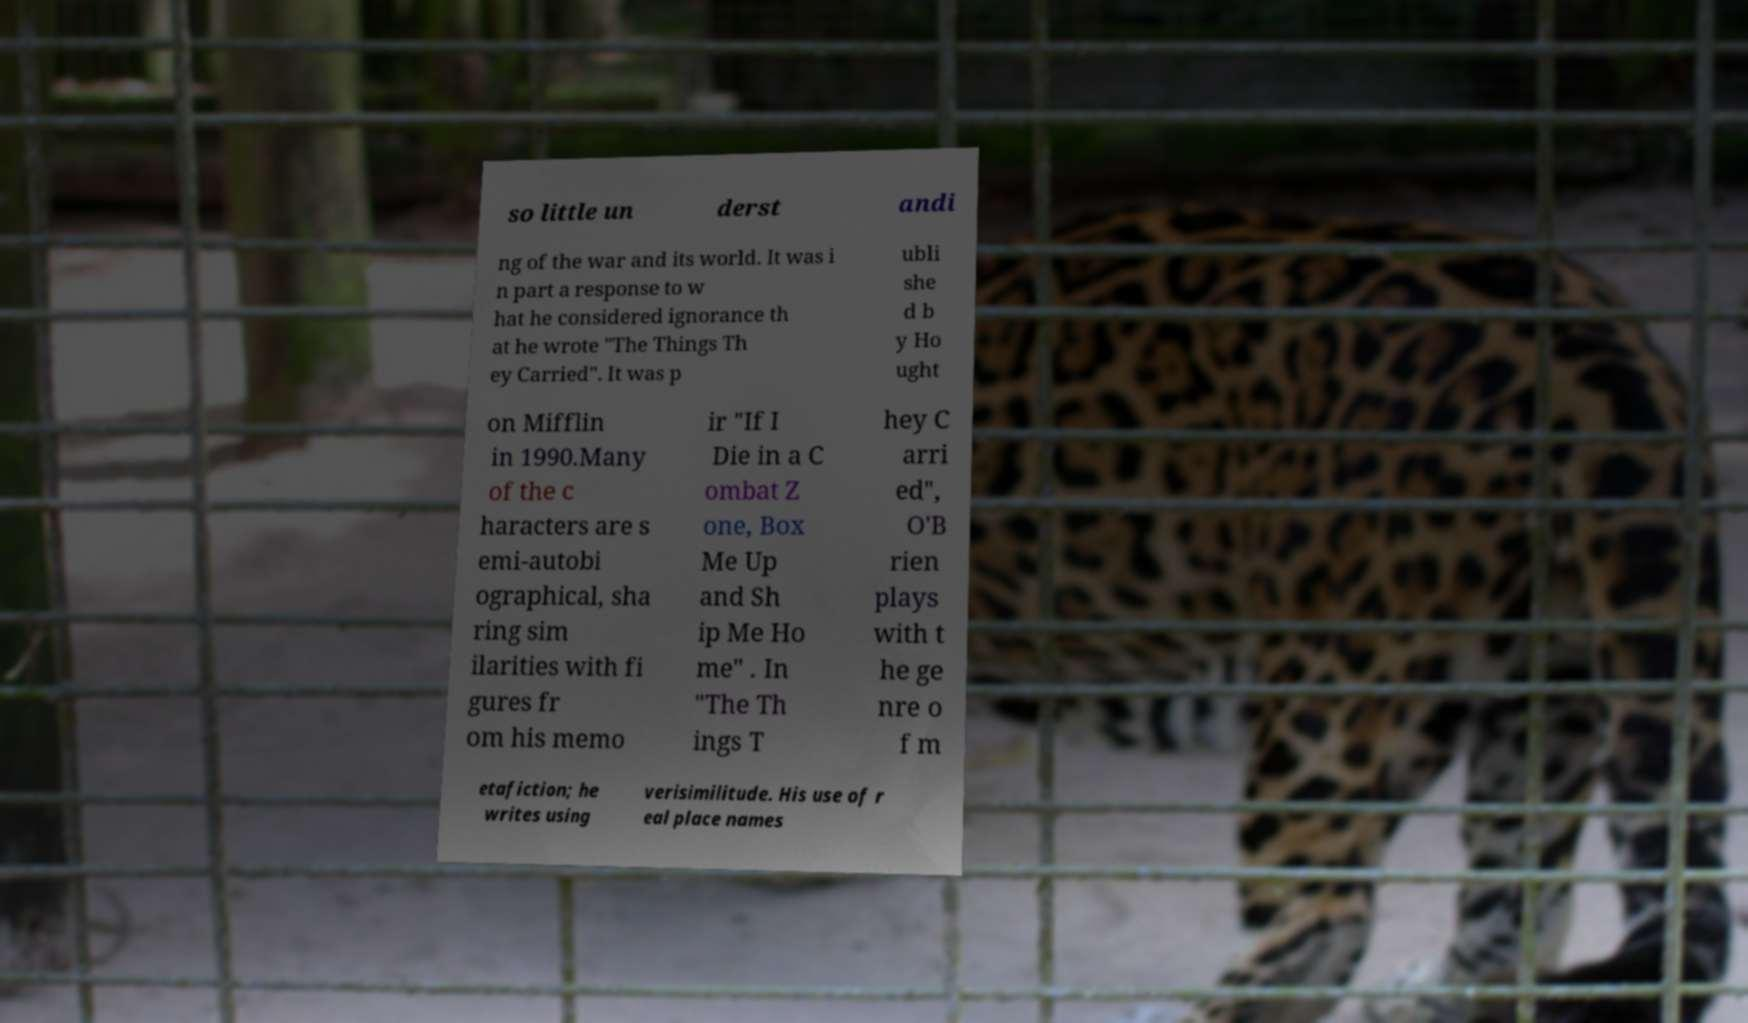Can you read and provide the text displayed in the image?This photo seems to have some interesting text. Can you extract and type it out for me? so little un derst andi ng of the war and its world. It was i n part a response to w hat he considered ignorance th at he wrote "The Things Th ey Carried". It was p ubli she d b y Ho ught on Mifflin in 1990.Many of the c haracters are s emi-autobi ographical, sha ring sim ilarities with fi gures fr om his memo ir "If I Die in a C ombat Z one, Box Me Up and Sh ip Me Ho me" . In "The Th ings T hey C arri ed", O'B rien plays with t he ge nre o f m etafiction; he writes using verisimilitude. His use of r eal place names 